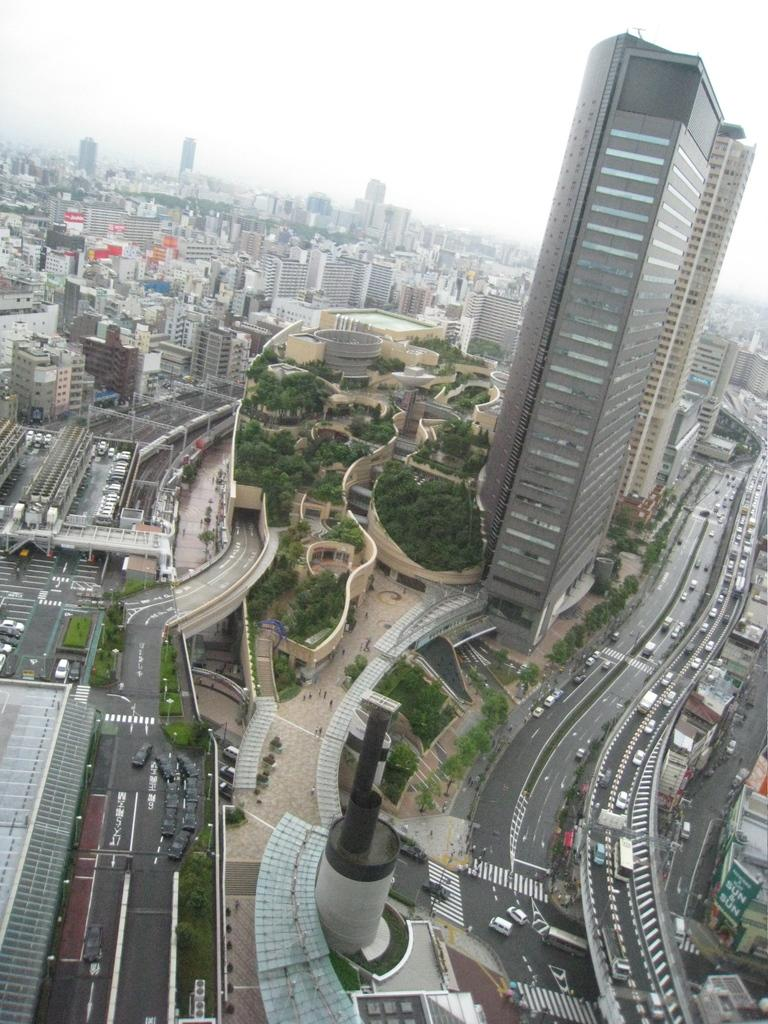What can be seen on the road in the image? There are vehicles on the road in the image. What type of structures are visible in the image? There are buildings visible in the image. What type of vegetation is present in the image? There are trees in the image. What is visible at the top of the image? The sky is visible at the top of the image. What type of prose is being recited by the trees in the image? There are no trees reciting prose in the image; they are simply trees. How does the grip of the buildings affect the vehicles on the road? The grip of the buildings does not affect the vehicles on the road, as buildings do not have grips. 